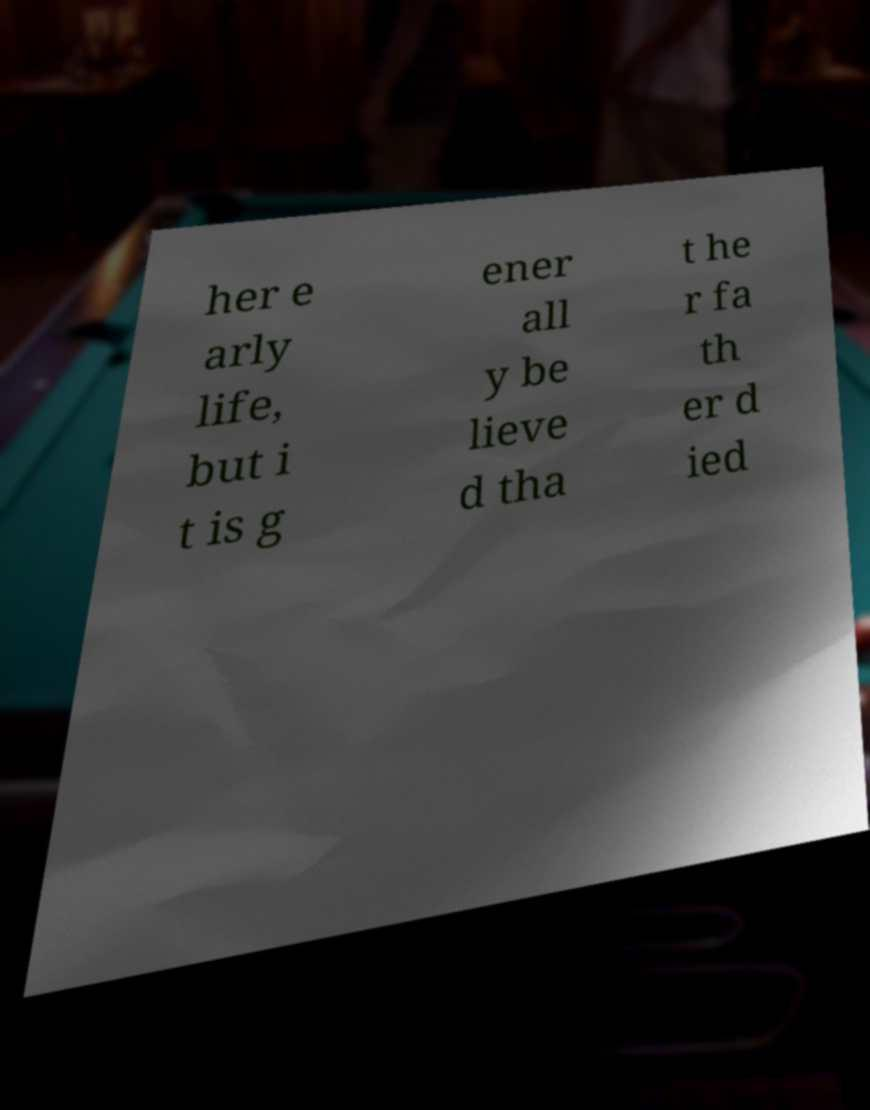I need the written content from this picture converted into text. Can you do that? her e arly life, but i t is g ener all y be lieve d tha t he r fa th er d ied 